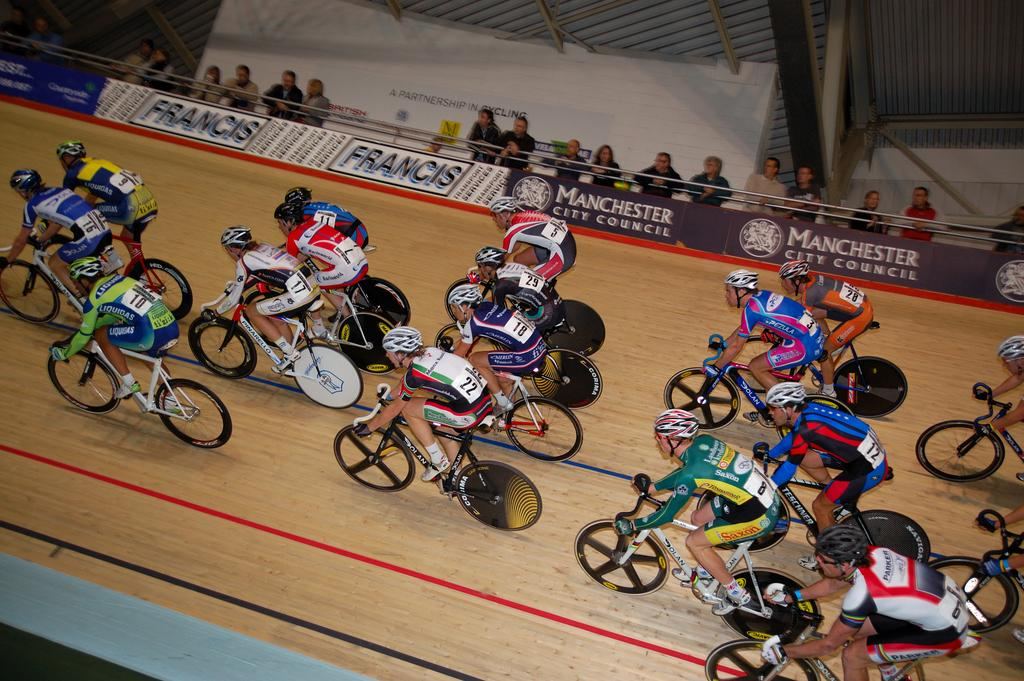What type of protective gear are the people wearing in the image? The people are wearing helmets and gloves in the image. What activity are the people engaged in while wearing this gear? The people are riding cycles in the image. What can be seen in the background of the image? There are banners in the background of the image. Are there any other people present in the image besides the ones riding cycles? Yes, there are people standing in the image. What type of protest is being held by the ladybug in the image? There is no ladybug present in the image, and therefore no protest can be observed. 